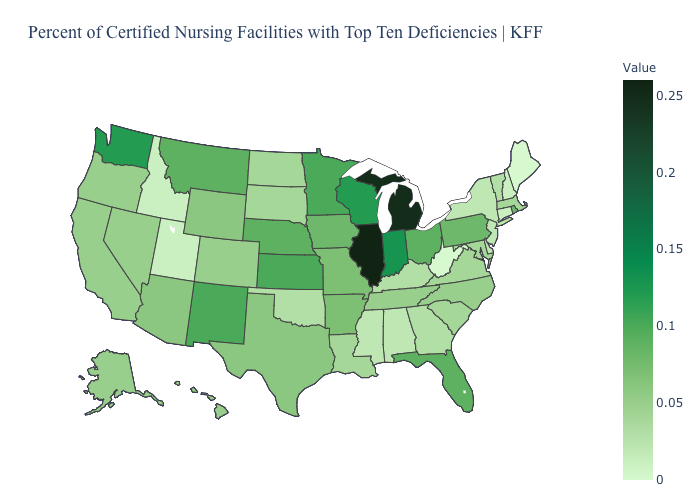Which states have the highest value in the USA?
Be succinct. Illinois. Among the states that border New York , which have the lowest value?
Answer briefly. Connecticut. Does the map have missing data?
Be succinct. No. Which states hav the highest value in the Northeast?
Quick response, please. Pennsylvania, Rhode Island. Does Ohio have the highest value in the MidWest?
Give a very brief answer. No. 